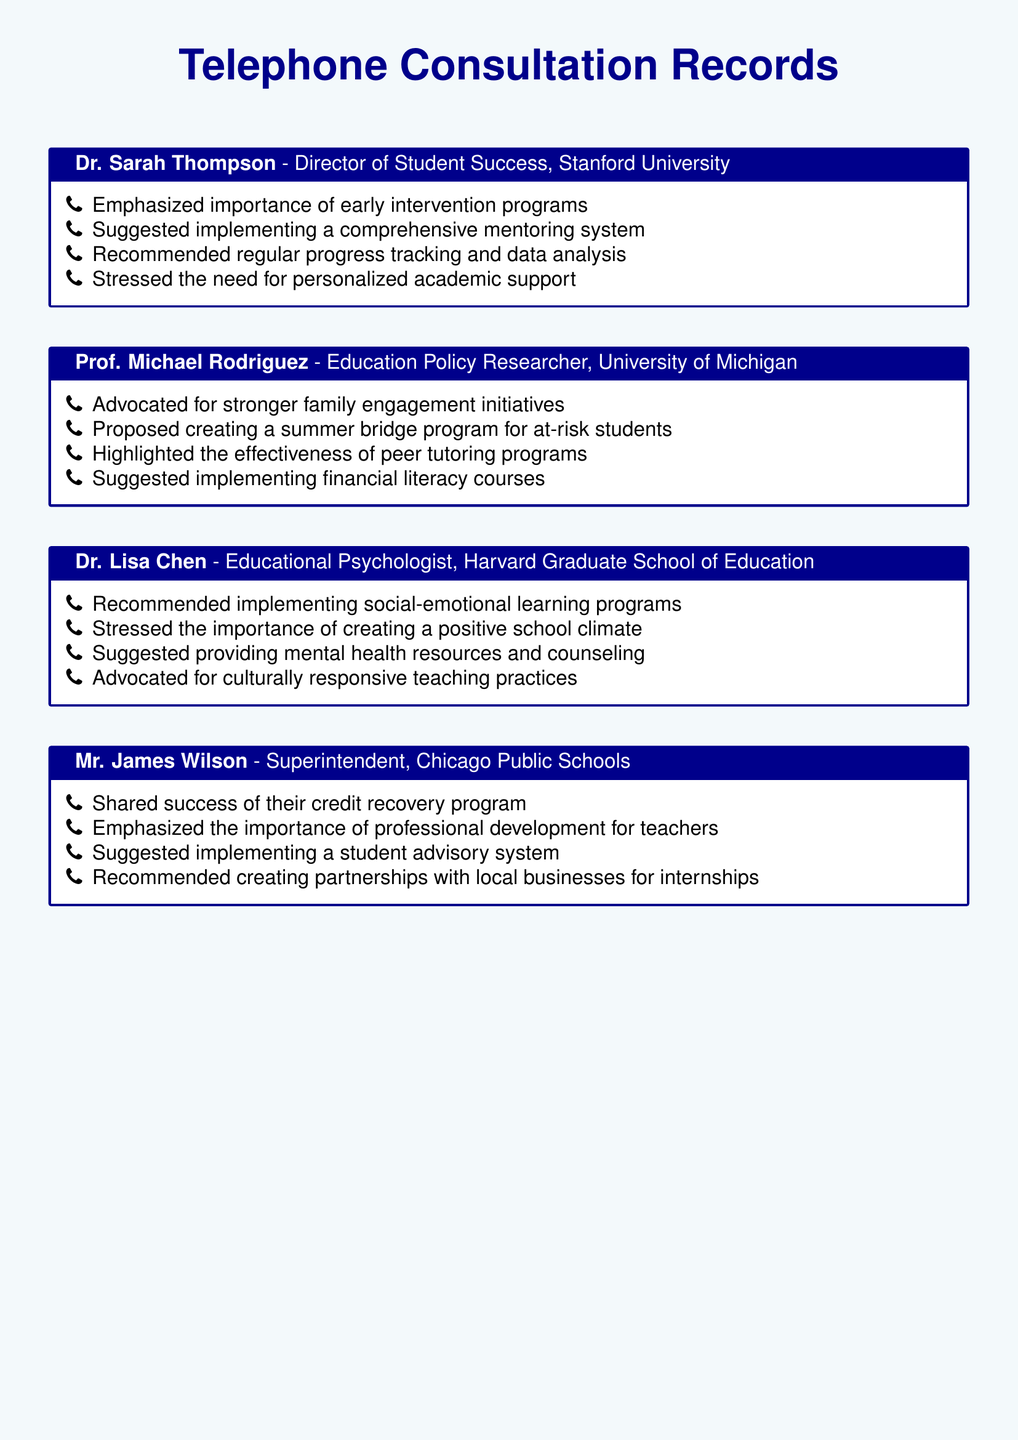What is Dr. Sarah Thompson's title? Dr. Sarah Thompson is identified as the Director of Student Success at Stanford University.
Answer: Director of Student Success What program did Prof. Michael Rodriguez suggest for at-risk students? Prof. Michael Rodriguez proposed creating a summer bridge program specifically for at-risk students.
Answer: Summer bridge program Which expert emphasized the need for personalized academic support? Dr. Sarah Thompson highlighted the necessity of personalized academic support during her consultation.
Answer: Dr. Sarah Thompson What did Mr. James Wilson share success on? Mr. James Wilson discussed the success of their credit recovery program in his consultation.
Answer: Credit recovery program What type of learning programs did Dr. Lisa Chen recommend? Dr. Lisa Chen recommended implementing social-emotional learning programs to support students.
Answer: Social-emotional learning programs How many experts contributed to the telephone consultation records? The document features consultations from four educational experts, making the total four.
Answer: Four 